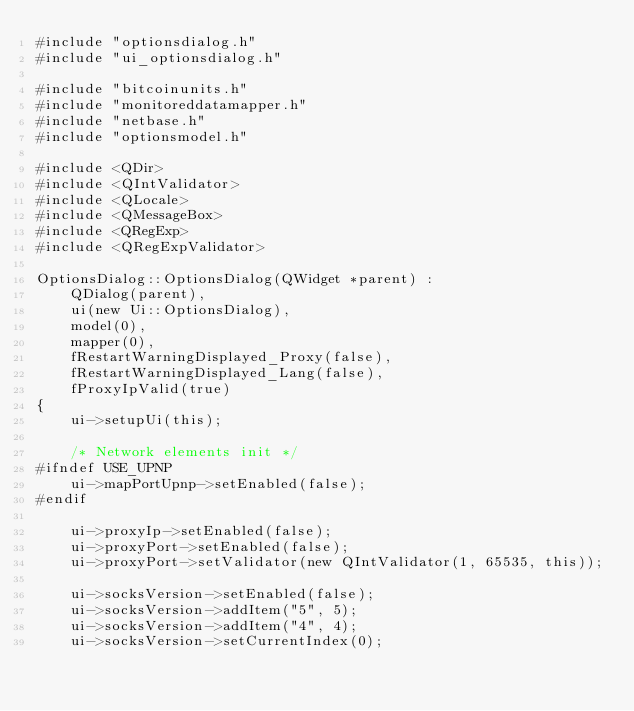<code> <loc_0><loc_0><loc_500><loc_500><_C++_>#include "optionsdialog.h"
#include "ui_optionsdialog.h"

#include "bitcoinunits.h"
#include "monitoreddatamapper.h"
#include "netbase.h"
#include "optionsmodel.h"

#include <QDir>
#include <QIntValidator>
#include <QLocale>
#include <QMessageBox>
#include <QRegExp>
#include <QRegExpValidator>

OptionsDialog::OptionsDialog(QWidget *parent) :
    QDialog(parent),
    ui(new Ui::OptionsDialog),
    model(0),
    mapper(0),
    fRestartWarningDisplayed_Proxy(false),
    fRestartWarningDisplayed_Lang(false),
    fProxyIpValid(true)
{
    ui->setupUi(this);

    /* Network elements init */
#ifndef USE_UPNP
    ui->mapPortUpnp->setEnabled(false);
#endif

    ui->proxyIp->setEnabled(false);
    ui->proxyPort->setEnabled(false);
    ui->proxyPort->setValidator(new QIntValidator(1, 65535, this));

    ui->socksVersion->setEnabled(false);
    ui->socksVersion->addItem("5", 5);
    ui->socksVersion->addItem("4", 4);
    ui->socksVersion->setCurrentIndex(0);
</code> 